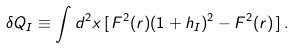<formula> <loc_0><loc_0><loc_500><loc_500>\delta Q _ { I } \equiv \int d ^ { 2 } x \, [ \, F ^ { 2 } ( r ) ( 1 + h _ { I } ) ^ { 2 } - F ^ { 2 } ( r ) \, ] \, .</formula> 